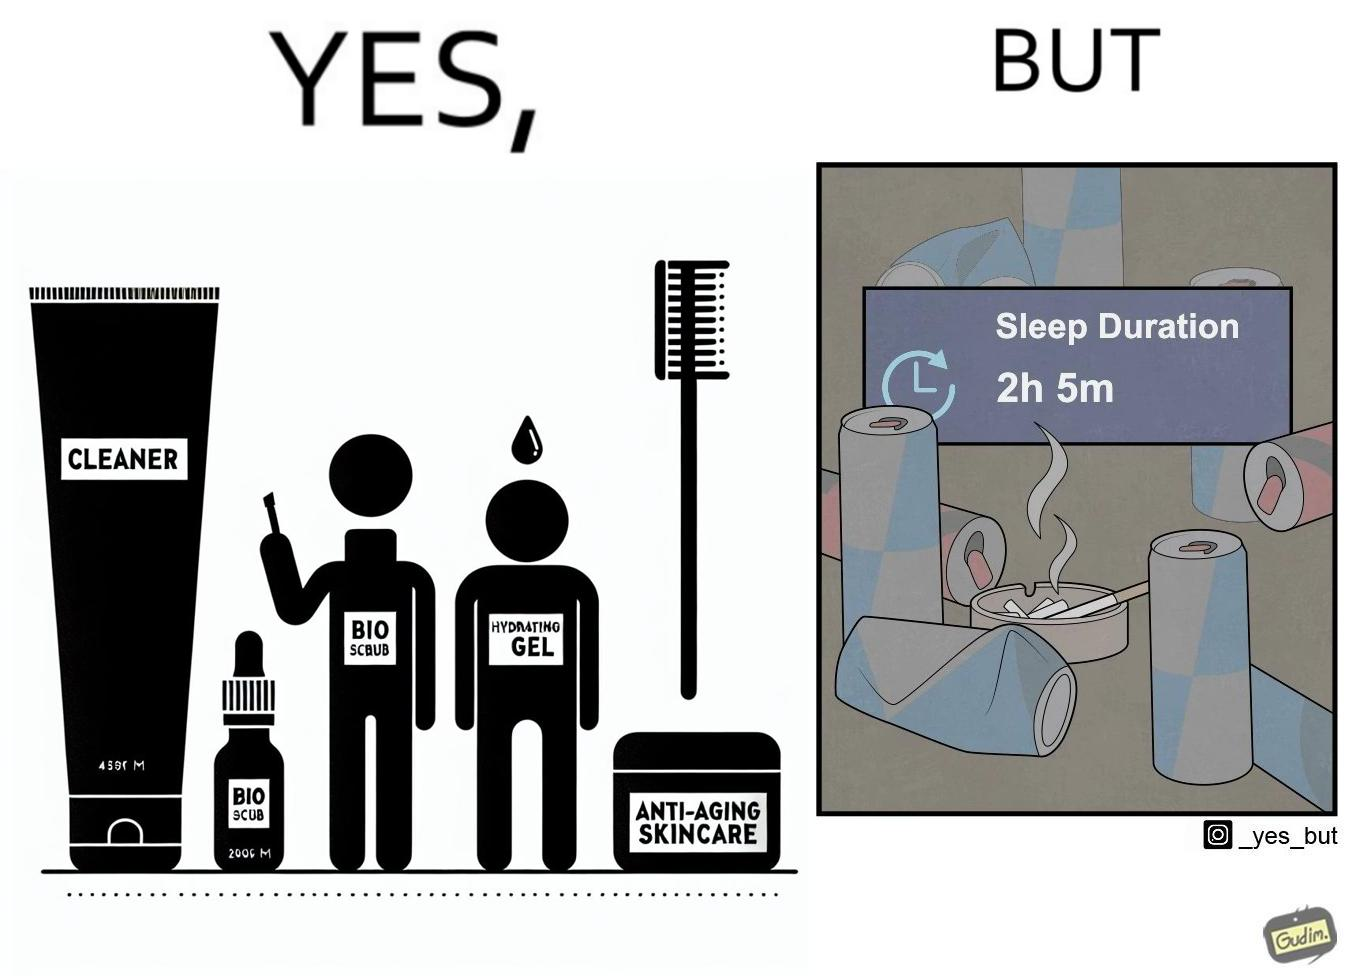What does this image depict? This image is ironic as on the one hand, the presumed person is into skincare and wants to do the best for their skin, which is good, but on the other hand, they are involved in unhealthy habits that will damage their skin like smoking, caffeine and inadequate sleep. 